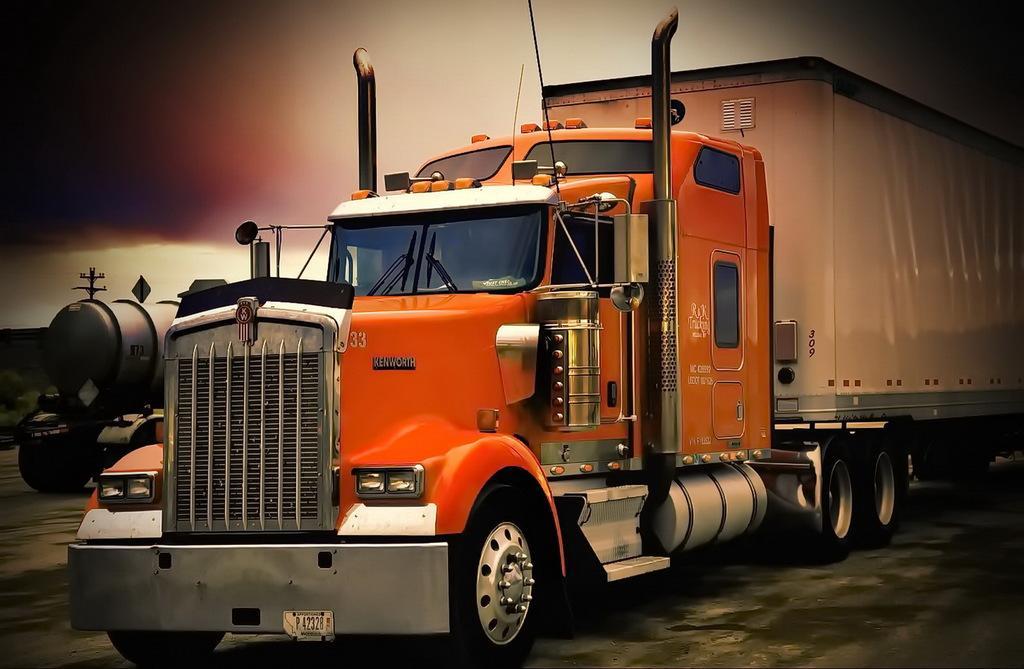Could you give a brief overview of what you see in this image? In this picture we can see there are two vehicles on the path and behind the vehicles there is a pole and sky. 